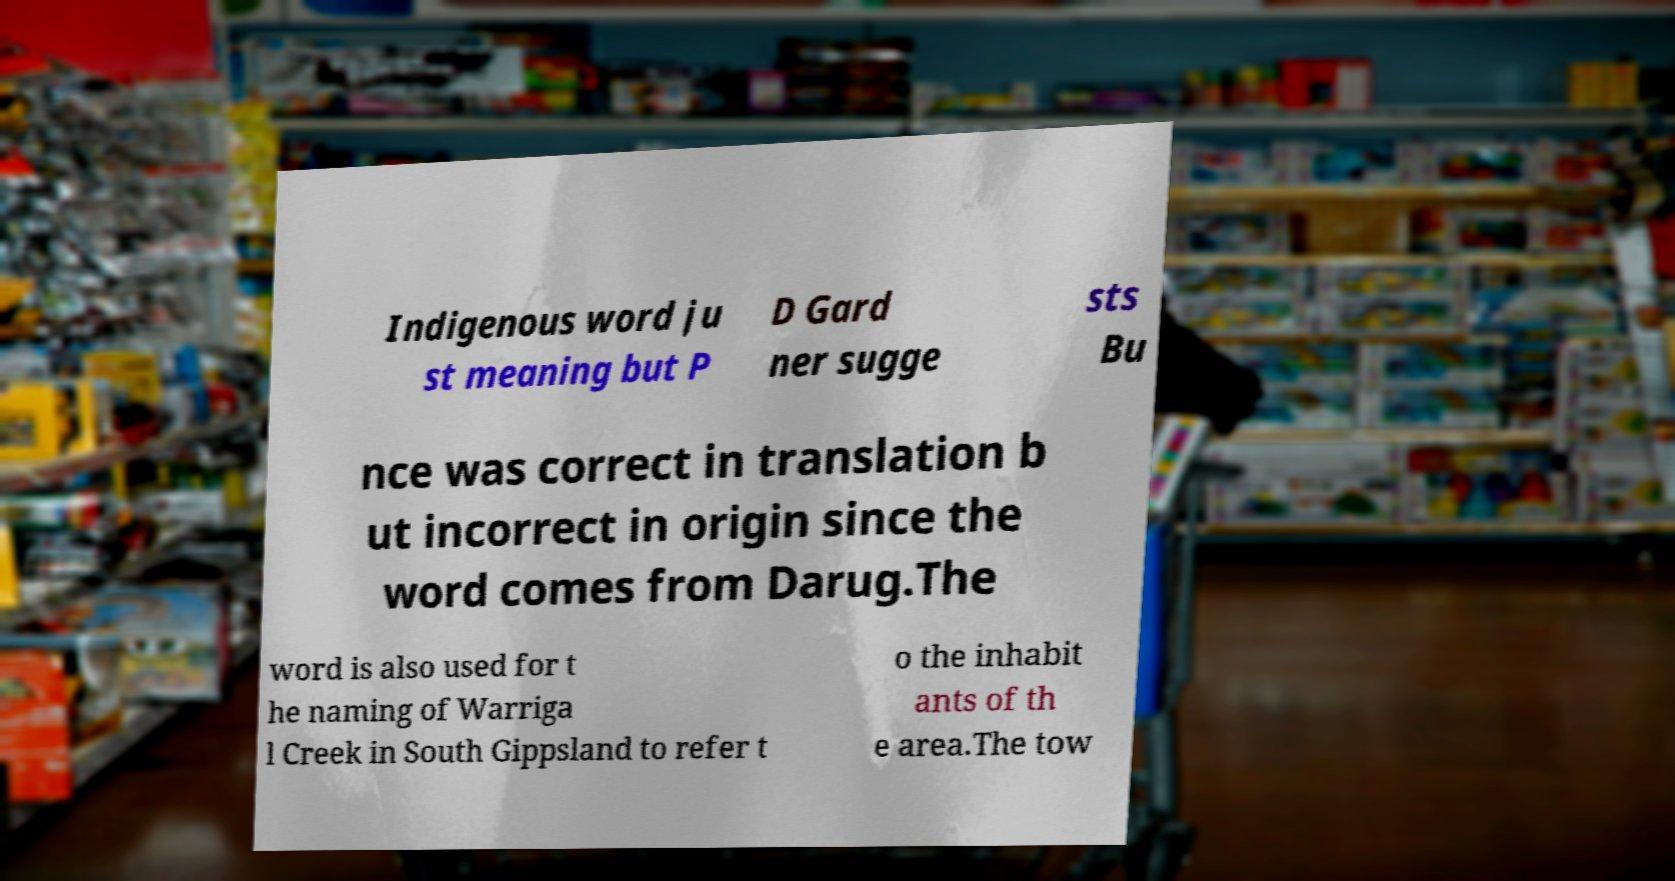Please identify and transcribe the text found in this image. Indigenous word ju st meaning but P D Gard ner sugge sts Bu nce was correct in translation b ut incorrect in origin since the word comes from Darug.The word is also used for t he naming of Warriga l Creek in South Gippsland to refer t o the inhabit ants of th e area.The tow 